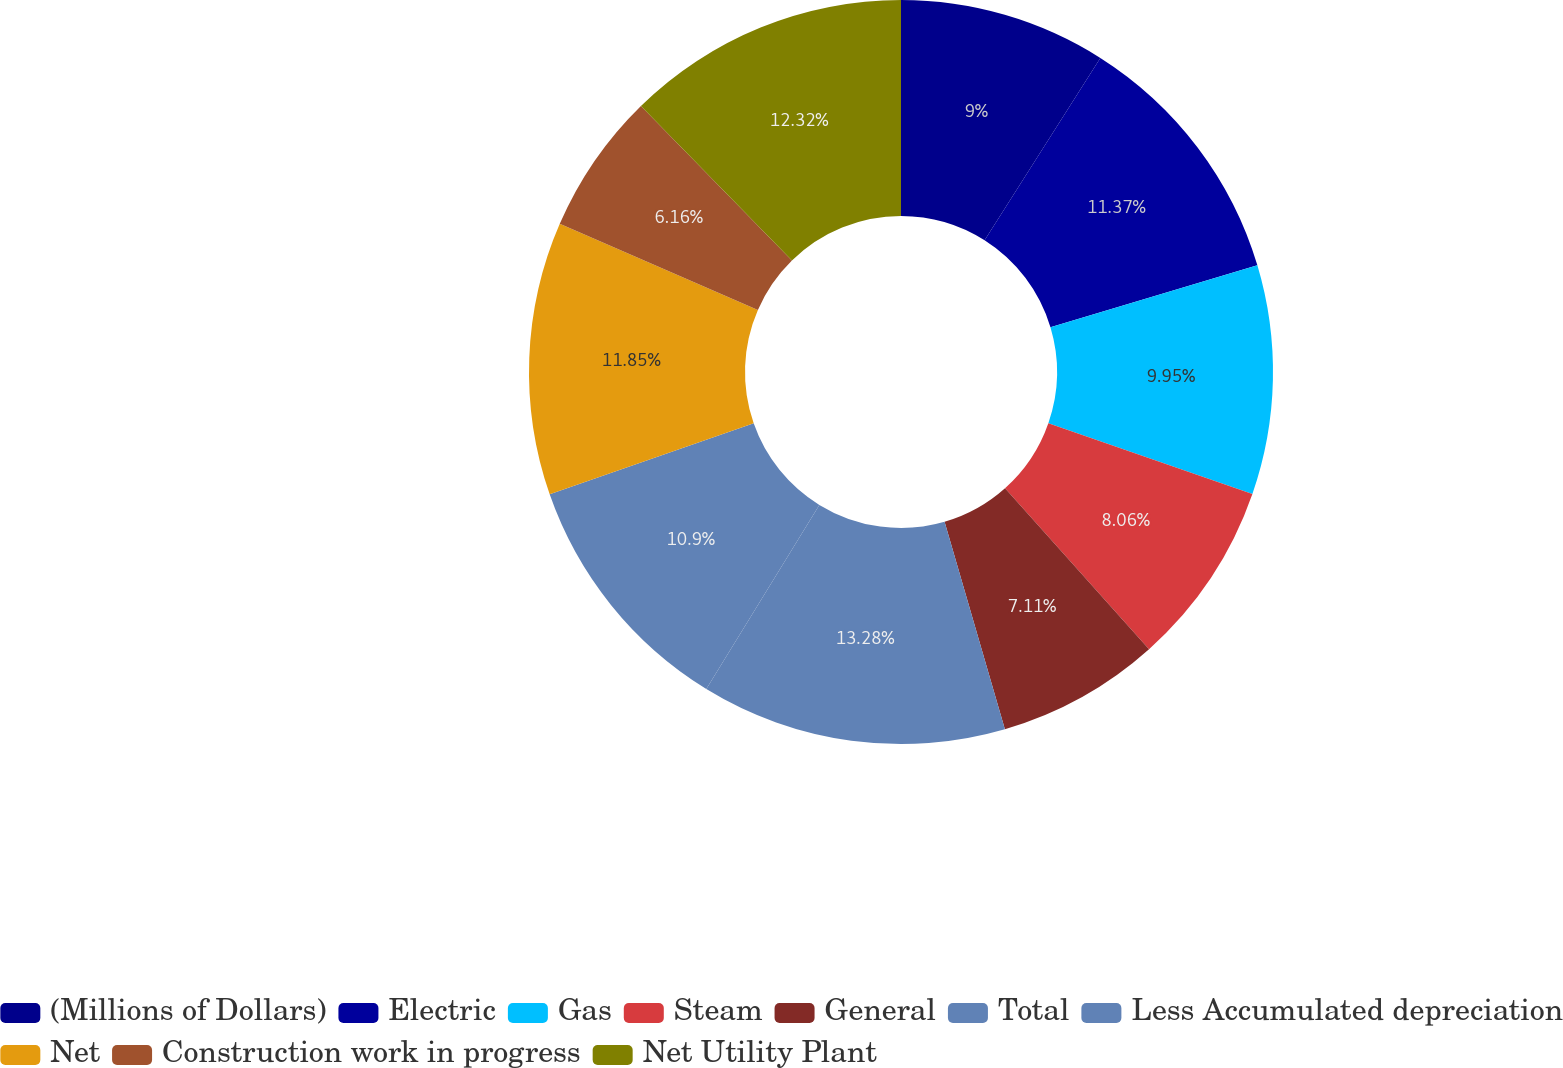<chart> <loc_0><loc_0><loc_500><loc_500><pie_chart><fcel>(Millions of Dollars)<fcel>Electric<fcel>Gas<fcel>Steam<fcel>General<fcel>Total<fcel>Less Accumulated depreciation<fcel>Net<fcel>Construction work in progress<fcel>Net Utility Plant<nl><fcel>9.0%<fcel>11.37%<fcel>9.95%<fcel>8.06%<fcel>7.11%<fcel>13.27%<fcel>10.9%<fcel>11.85%<fcel>6.16%<fcel>12.32%<nl></chart> 